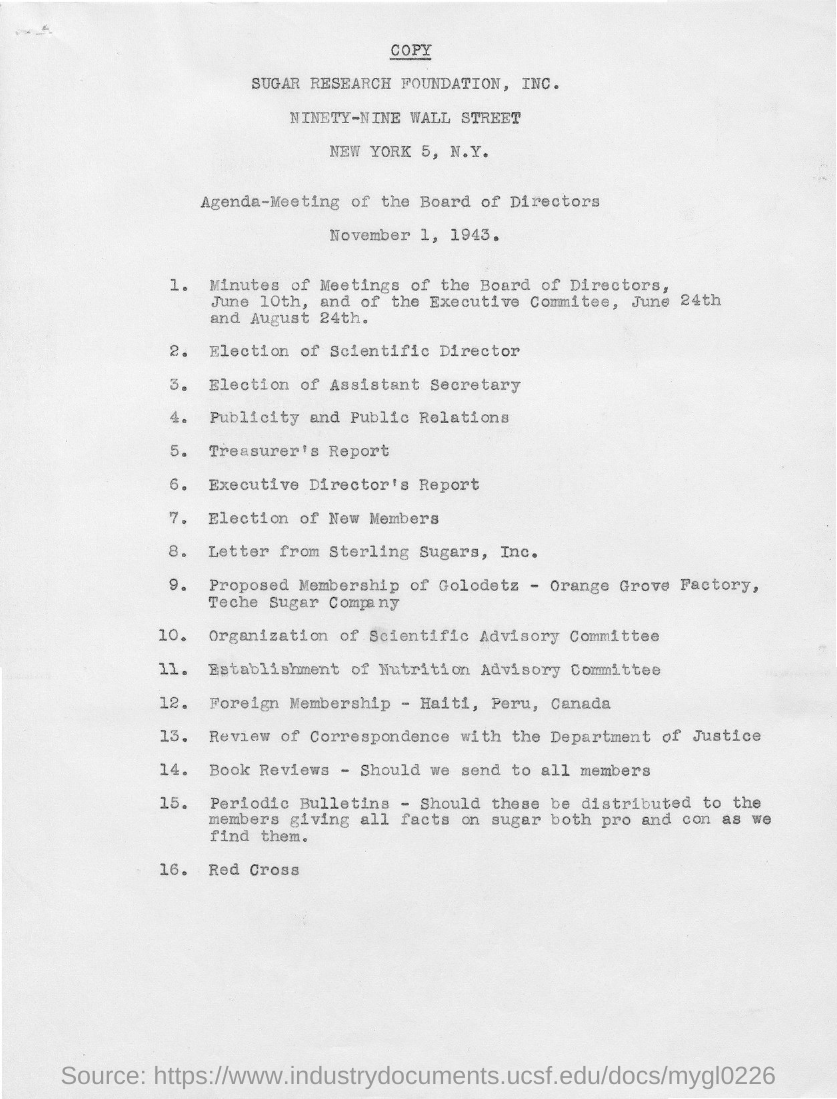Indicate a few pertinent items in this graphic. There are 16 agendas for the meeting. The last agenda is about the Red Cross. The second agenda item is the election of a scientific director. The meeting date is November 1, 1943. The agenda for the meeting of the board of directors is as follows: 